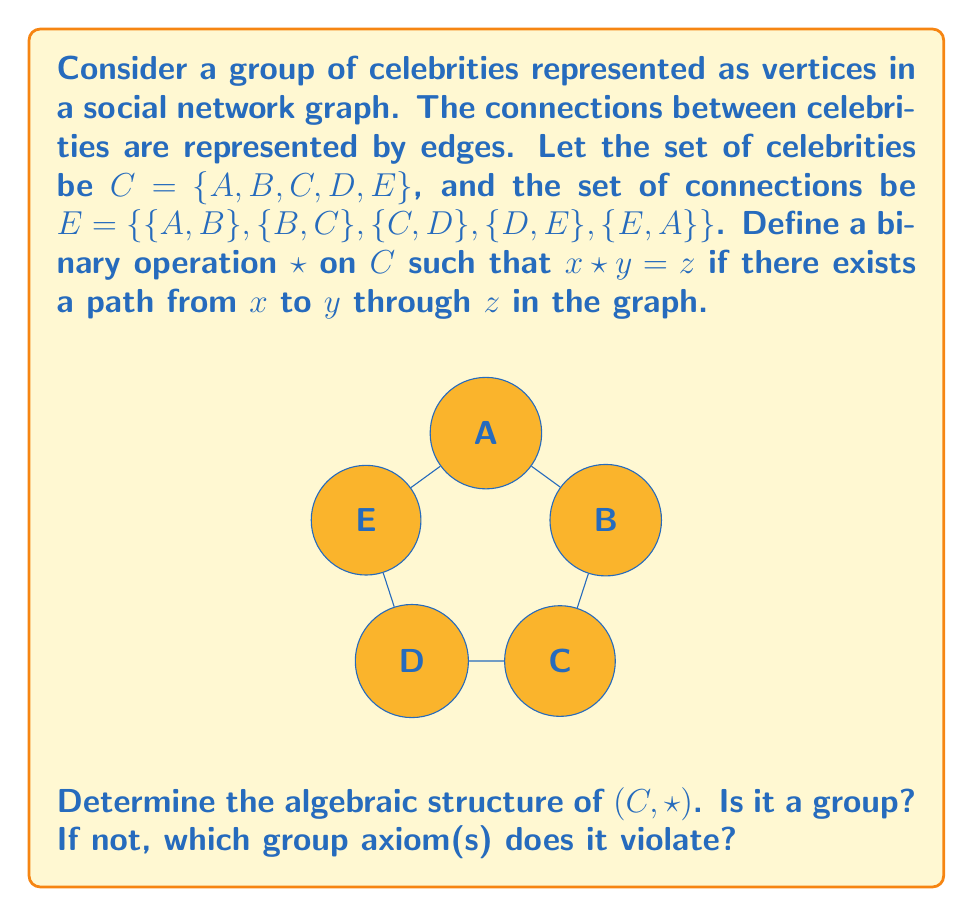Can you answer this question? To determine the algebraic structure of $(C, \star)$, we need to check if it satisfies the four group axioms: closure, associativity, identity, and inverse.

1. Closure:
   For any $x, y \in C$, $x \star y$ is defined and is in $C$. This property holds.

2. Associativity:
   Let's check if $(x \star y) \star z = x \star (y \star z)$ for all $x, y, z \in C$.
   
   Counter-example: $(A \star B) \star D \neq A \star (B \star D)$
   - $(A \star B) \star D = B \star D = C$
   - $A \star (B \star D) = A \star C = B$

   Associativity does not hold.

3. Identity:
   There is no element $e \in C$ such that $x \star e = e \star x = x$ for all $x \in C$.
   For any potential identity element, it would need to be connected to all other vertices, which is not the case in this graph.

4. Inverse:
   Since there is no identity element, we cannot define inverses.

Given that associativity and the existence of an identity element (and consequently, inverses) do not hold, $(C, \star)$ is not a group.

The algebraic structure $(C, \star)$ is a magma, which is a set with a closed binary operation. It does not form a semigroup, monoid, or group due to the lack of associativity and identity.
Answer: Not a group; violates associativity and lacks identity 